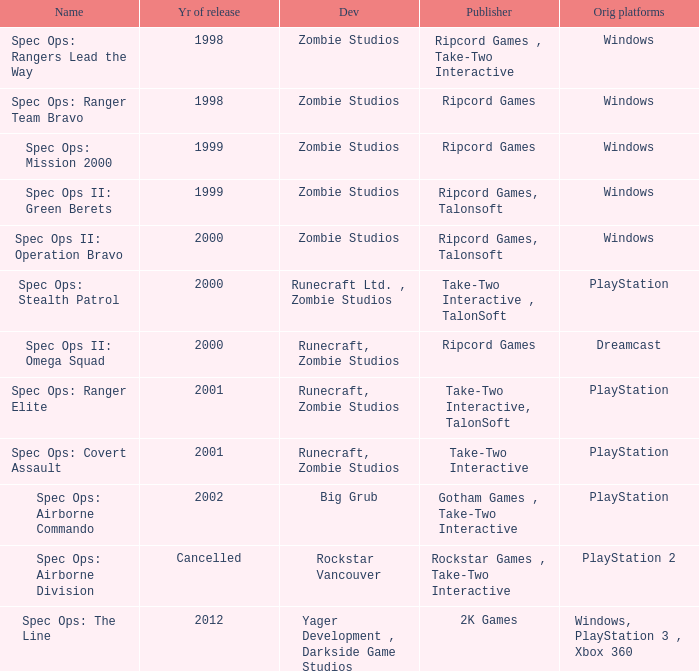Which publisher has release year of 2000 and an original dreamcast platform? Ripcord Games. 